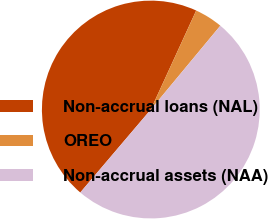Convert chart. <chart><loc_0><loc_0><loc_500><loc_500><pie_chart><fcel>Non-accrual loans (NAL)<fcel>OREO<fcel>Non-accrual assets (NAA)<nl><fcel>45.63%<fcel>4.18%<fcel>50.19%<nl></chart> 